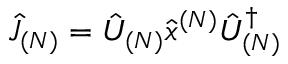Convert formula to latex. <formula><loc_0><loc_0><loc_500><loc_500>\hat { J } _ { ( N ) } = \hat { U } _ { ( N ) } \hat { x } ^ { ( N ) } \hat { U } _ { ( N ) } ^ { \dagger }</formula> 